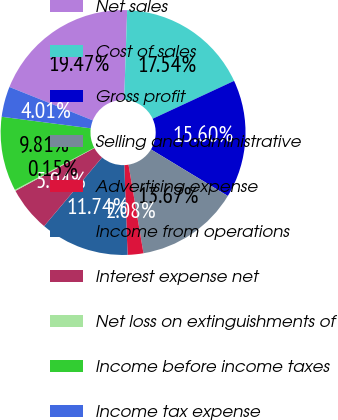<chart> <loc_0><loc_0><loc_500><loc_500><pie_chart><fcel>Net sales<fcel>Cost of sales<fcel>Gross profit<fcel>Selling and administrative<fcel>Advertising expense<fcel>Income from operations<fcel>Interest expense net<fcel>Net loss on extinguishments of<fcel>Income before income taxes<fcel>Income tax expense<nl><fcel>19.47%<fcel>17.54%<fcel>15.6%<fcel>13.67%<fcel>2.08%<fcel>11.74%<fcel>5.94%<fcel>0.15%<fcel>9.81%<fcel>4.01%<nl></chart> 